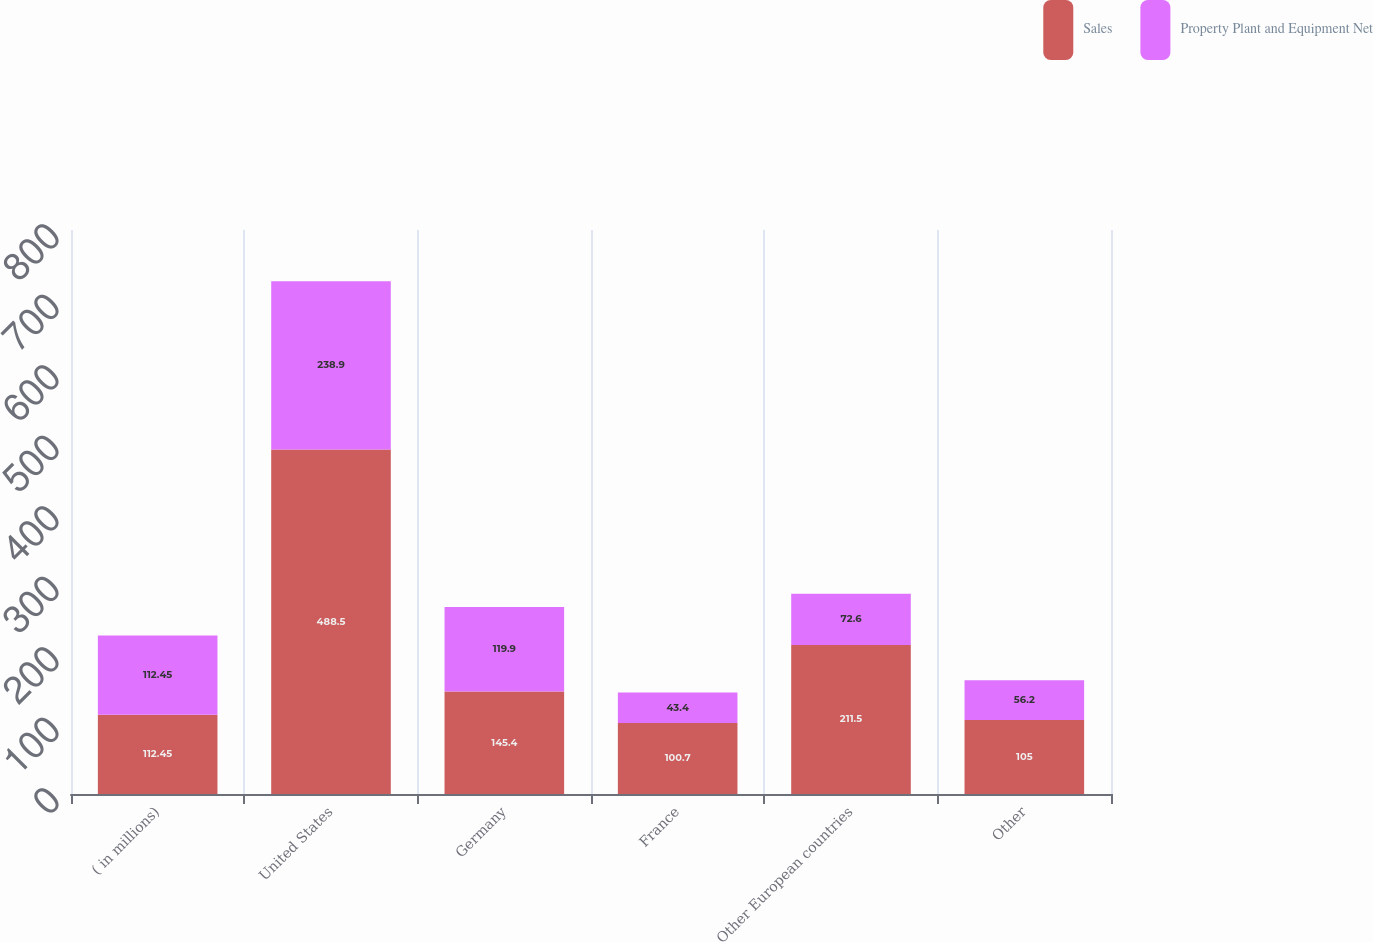<chart> <loc_0><loc_0><loc_500><loc_500><stacked_bar_chart><ecel><fcel>( in millions)<fcel>United States<fcel>Germany<fcel>France<fcel>Other European countries<fcel>Other<nl><fcel>Sales<fcel>112.45<fcel>488.5<fcel>145.4<fcel>100.7<fcel>211.5<fcel>105<nl><fcel>Property Plant and Equipment Net<fcel>112.45<fcel>238.9<fcel>119.9<fcel>43.4<fcel>72.6<fcel>56.2<nl></chart> 